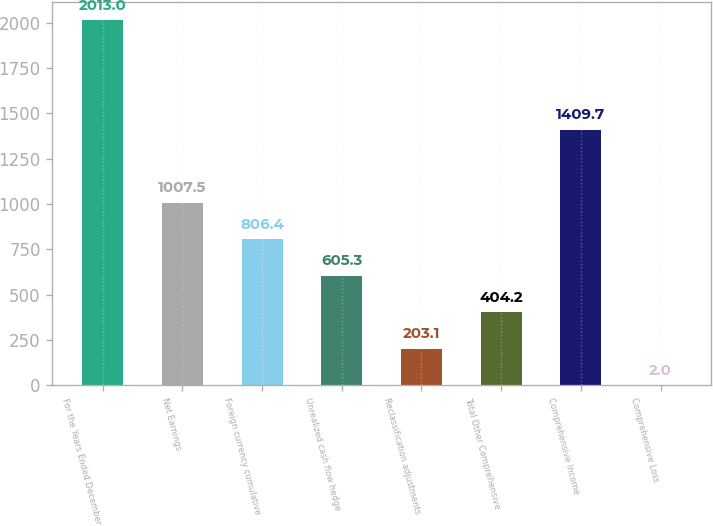Convert chart. <chart><loc_0><loc_0><loc_500><loc_500><bar_chart><fcel>For the Years Ended December<fcel>Net Earnings<fcel>Foreign currency cumulative<fcel>Unrealized cash flow hedge<fcel>Reclassification adjustments<fcel>Total Other Comprehensive<fcel>Comprehensive Income<fcel>Comprehensive Loss<nl><fcel>2013<fcel>1007.5<fcel>806.4<fcel>605.3<fcel>203.1<fcel>404.2<fcel>1409.7<fcel>2<nl></chart> 